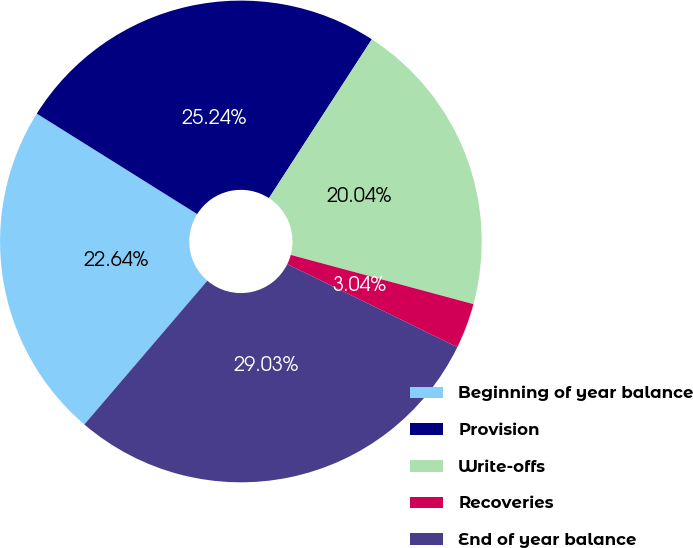Convert chart to OTSL. <chart><loc_0><loc_0><loc_500><loc_500><pie_chart><fcel>Beginning of year balance<fcel>Provision<fcel>Write-offs<fcel>Recoveries<fcel>End of year balance<nl><fcel>22.64%<fcel>25.24%<fcel>20.04%<fcel>3.04%<fcel>29.03%<nl></chart> 